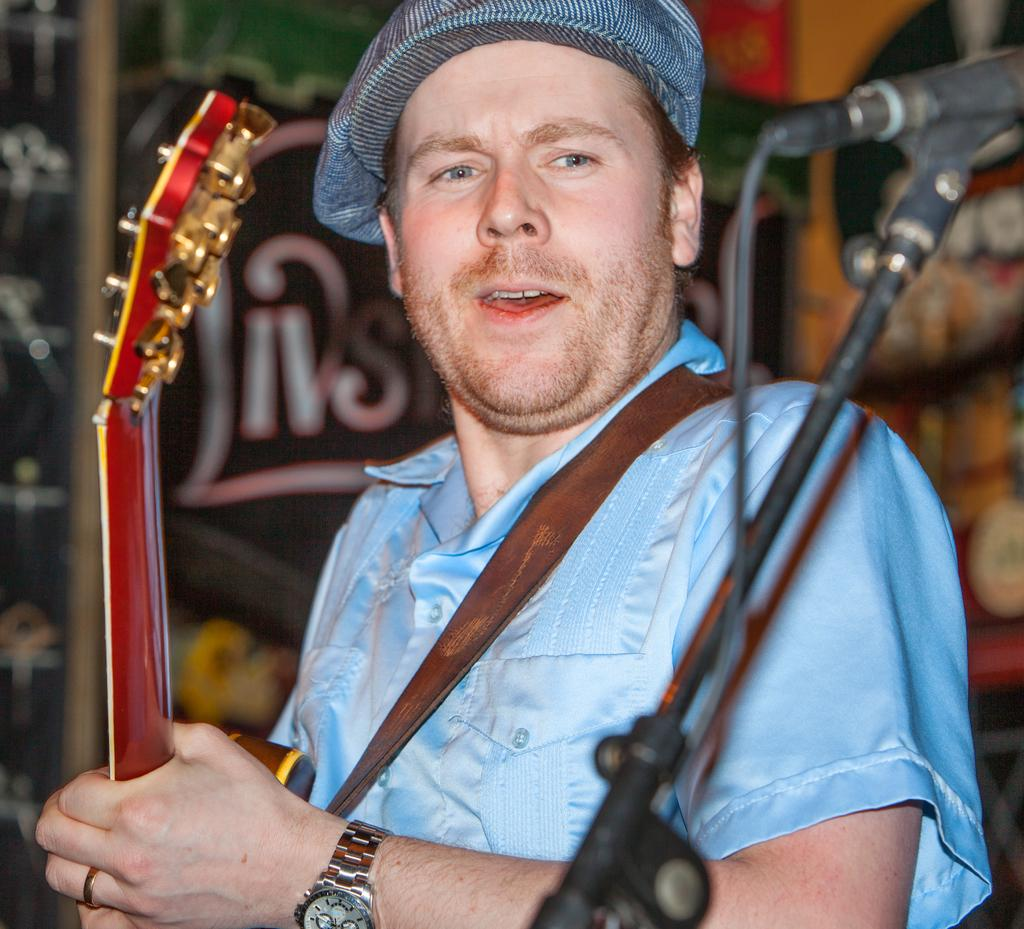What can be seen in the image? There is a person in the image. Can you describe the person's attire? The person is wearing a cap. What is the person holding in the image? The person is holding a musical instrument. What other object related to sound can be seen in the image? There is a microphone (mic) in the image. What is the background of the image? The background of the image appears to be a wall. How many kittens are sitting on the person's lap in the image? There are no kittens present in the image. What type of zipper can be seen on the person's clothing in the image? There is no zipper visible on the person's clothing in the image. 